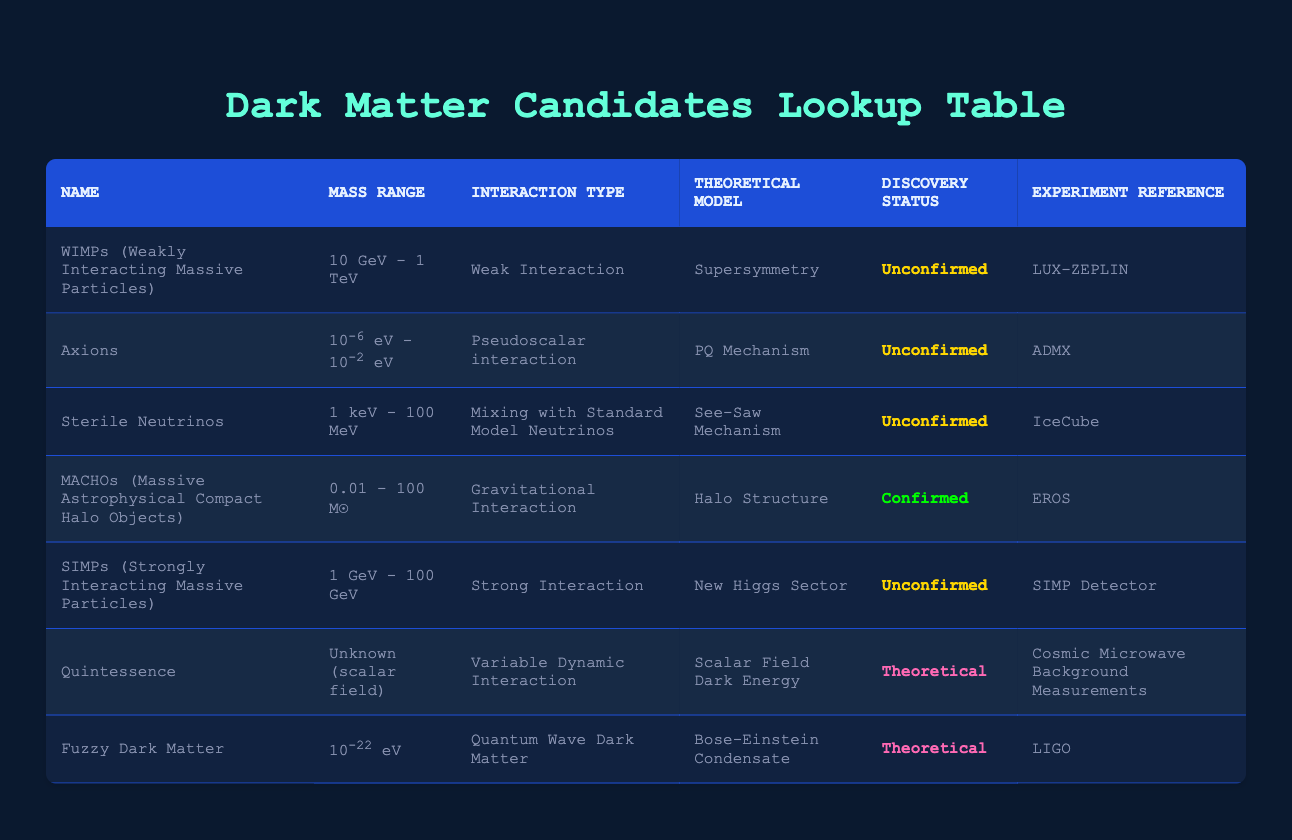What is the mass range of WIMPs? The table states that WIMPs (Weakly Interacting Massive Particles) have a mass range of 10 GeV - 1 TeV.
Answer: 10 GeV - 1 TeV Which candidates are confirmed? By examining the discovery status column, we see that the only confirmed candidate is MACHOs (Massive Astrophysical Compact Halo Objects).
Answer: MACHOs Is the interaction type of Axions a weak interaction? Looking at the interaction type for Axions, it shows "Pseudoscalar interaction," which is not a weak interaction.
Answer: No How many candidates have an unconfirmed discovery status? Counting the rows in the discovery status column that state "Unconfirmed," we find that there are five candidates with this status.
Answer: 5 What theoretical model is associated with Fuzzy Dark Matter? The table indicates that Fuzzy Dark Matter is associated with the "Bose-Einstein Condensate" theoretical model.
Answer: Bose-Einstein Condensate Identify the candidate with the largest mass range. Comparing the mass ranges, MACHOs have the largest mass range of 0.01 - 100 M☉, making it the candidate with the largest range.
Answer: MACHOs What is the difference in mass range between WIMPs and SIMPs? The mass range of WIMPs is 10 GeV - 1 TeV (or approximately 10,000 GeV) while SIMPs range from 1 GeV - 100 GeV. Therefore, to find the difference, we note the maximum values (1000 GeV for WIMPs and 100 GeV for SIMPs). The difference is 1000 GeV - 100 GeV = 900 GeV.
Answer: 900 GeV Are there any candidates that have both a theoretical status and a theoretical model listed as unknown? Checking candidates with a theoretical status, we see two: Quintessence and Fuzzy Dark Matter. However, only Quintessence has its mass range listed as unknown while Fuzzy Dark Matter provides a specific value. Thus, there is one candidate fitting the criteria.
Answer: Yes Which candidate would you reference for the "See-Saw Mechanism"? The table specifies that Sterile Neutrinos are associated with the "See-Saw Mechanism."
Answer: Sterile Neutrinos 